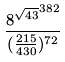Convert formula to latex. <formula><loc_0><loc_0><loc_500><loc_500>\frac { { 8 ^ { \sqrt { 4 3 } } } ^ { 3 8 2 } } { ( \frac { 2 1 5 } { 4 3 0 } ) ^ { 7 2 } }</formula> 